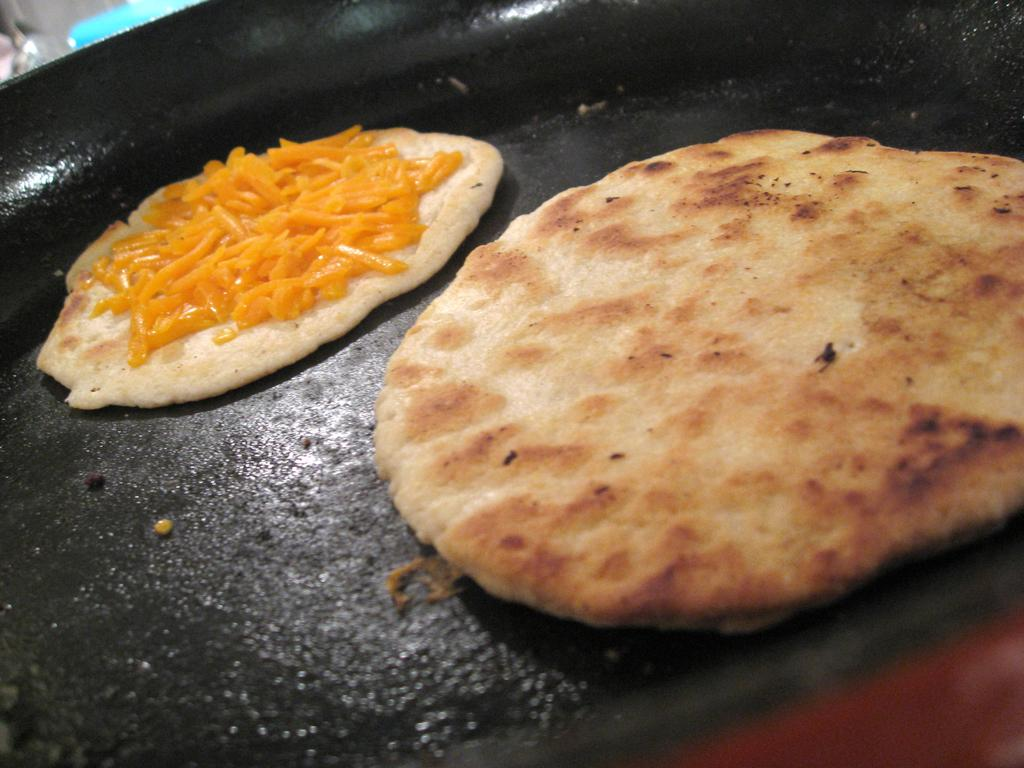What is the color of the pan in the image? The pan in the image is black. What is on the pan in the image? There are food items on the pan in the image. What letter is written on the chin of the person in the image? There is no person present in the image, and therefore no chin or letter written on it. 